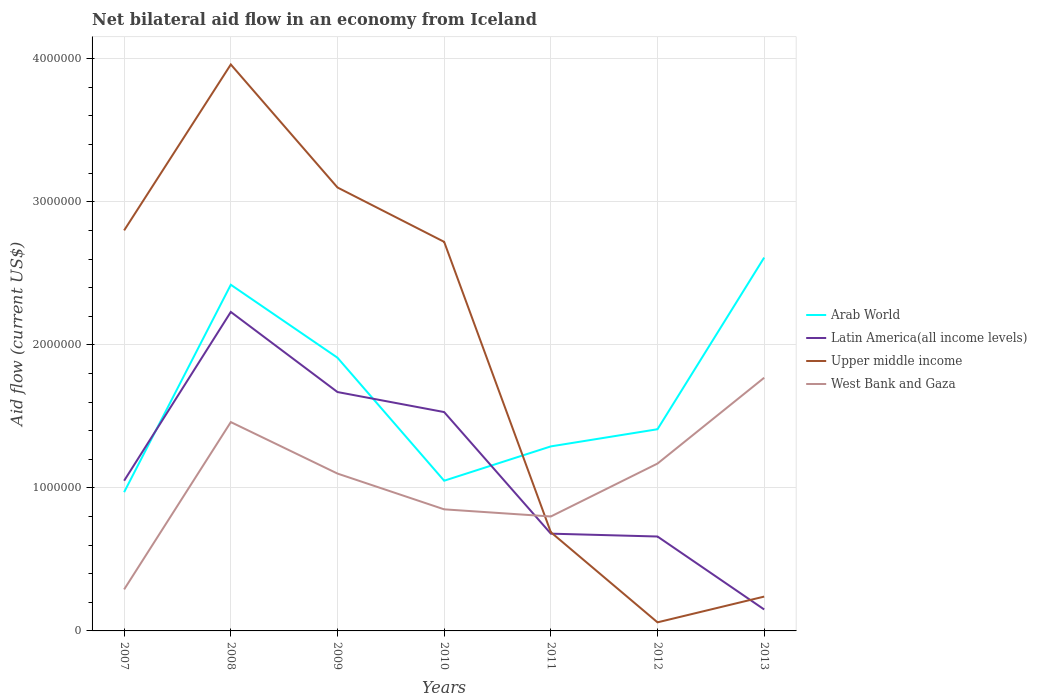Does the line corresponding to Upper middle income intersect with the line corresponding to Latin America(all income levels)?
Give a very brief answer. Yes. Is the number of lines equal to the number of legend labels?
Offer a terse response. Yes. What is the total net bilateral aid flow in West Bank and Gaza in the graph?
Your answer should be compact. -7.00e+04. What is the difference between the highest and the second highest net bilateral aid flow in Upper middle income?
Provide a short and direct response. 3.90e+06. How many lines are there?
Offer a terse response. 4. How many years are there in the graph?
Keep it short and to the point. 7. What is the difference between two consecutive major ticks on the Y-axis?
Ensure brevity in your answer.  1.00e+06. Does the graph contain any zero values?
Offer a very short reply. No. Does the graph contain grids?
Provide a short and direct response. Yes. Where does the legend appear in the graph?
Your answer should be compact. Center right. What is the title of the graph?
Provide a succinct answer. Net bilateral aid flow in an economy from Iceland. Does "South Sudan" appear as one of the legend labels in the graph?
Offer a terse response. No. What is the label or title of the Y-axis?
Your answer should be very brief. Aid flow (current US$). What is the Aid flow (current US$) of Arab World in 2007?
Your answer should be very brief. 9.70e+05. What is the Aid flow (current US$) of Latin America(all income levels) in 2007?
Your answer should be very brief. 1.05e+06. What is the Aid flow (current US$) of Upper middle income in 2007?
Keep it short and to the point. 2.80e+06. What is the Aid flow (current US$) in West Bank and Gaza in 2007?
Your answer should be compact. 2.90e+05. What is the Aid flow (current US$) of Arab World in 2008?
Offer a very short reply. 2.42e+06. What is the Aid flow (current US$) of Latin America(all income levels) in 2008?
Your response must be concise. 2.23e+06. What is the Aid flow (current US$) of Upper middle income in 2008?
Provide a short and direct response. 3.96e+06. What is the Aid flow (current US$) in West Bank and Gaza in 2008?
Offer a terse response. 1.46e+06. What is the Aid flow (current US$) in Arab World in 2009?
Ensure brevity in your answer.  1.91e+06. What is the Aid flow (current US$) in Latin America(all income levels) in 2009?
Provide a short and direct response. 1.67e+06. What is the Aid flow (current US$) in Upper middle income in 2009?
Make the answer very short. 3.10e+06. What is the Aid flow (current US$) of West Bank and Gaza in 2009?
Provide a short and direct response. 1.10e+06. What is the Aid flow (current US$) of Arab World in 2010?
Keep it short and to the point. 1.05e+06. What is the Aid flow (current US$) in Latin America(all income levels) in 2010?
Provide a short and direct response. 1.53e+06. What is the Aid flow (current US$) of Upper middle income in 2010?
Make the answer very short. 2.72e+06. What is the Aid flow (current US$) of West Bank and Gaza in 2010?
Your answer should be compact. 8.50e+05. What is the Aid flow (current US$) of Arab World in 2011?
Your response must be concise. 1.29e+06. What is the Aid flow (current US$) of Latin America(all income levels) in 2011?
Your answer should be compact. 6.80e+05. What is the Aid flow (current US$) in Upper middle income in 2011?
Keep it short and to the point. 6.90e+05. What is the Aid flow (current US$) of Arab World in 2012?
Provide a succinct answer. 1.41e+06. What is the Aid flow (current US$) of Upper middle income in 2012?
Provide a short and direct response. 6.00e+04. What is the Aid flow (current US$) in West Bank and Gaza in 2012?
Keep it short and to the point. 1.17e+06. What is the Aid flow (current US$) in Arab World in 2013?
Provide a short and direct response. 2.61e+06. What is the Aid flow (current US$) in West Bank and Gaza in 2013?
Your answer should be compact. 1.77e+06. Across all years, what is the maximum Aid flow (current US$) in Arab World?
Your answer should be very brief. 2.61e+06. Across all years, what is the maximum Aid flow (current US$) in Latin America(all income levels)?
Offer a very short reply. 2.23e+06. Across all years, what is the maximum Aid flow (current US$) in Upper middle income?
Keep it short and to the point. 3.96e+06. Across all years, what is the maximum Aid flow (current US$) of West Bank and Gaza?
Offer a very short reply. 1.77e+06. Across all years, what is the minimum Aid flow (current US$) in Arab World?
Your answer should be very brief. 9.70e+05. Across all years, what is the minimum Aid flow (current US$) in West Bank and Gaza?
Your answer should be compact. 2.90e+05. What is the total Aid flow (current US$) in Arab World in the graph?
Your response must be concise. 1.17e+07. What is the total Aid flow (current US$) of Latin America(all income levels) in the graph?
Your response must be concise. 7.97e+06. What is the total Aid flow (current US$) of Upper middle income in the graph?
Make the answer very short. 1.36e+07. What is the total Aid flow (current US$) of West Bank and Gaza in the graph?
Offer a very short reply. 7.44e+06. What is the difference between the Aid flow (current US$) of Arab World in 2007 and that in 2008?
Make the answer very short. -1.45e+06. What is the difference between the Aid flow (current US$) of Latin America(all income levels) in 2007 and that in 2008?
Offer a terse response. -1.18e+06. What is the difference between the Aid flow (current US$) in Upper middle income in 2007 and that in 2008?
Offer a terse response. -1.16e+06. What is the difference between the Aid flow (current US$) in West Bank and Gaza in 2007 and that in 2008?
Give a very brief answer. -1.17e+06. What is the difference between the Aid flow (current US$) in Arab World in 2007 and that in 2009?
Ensure brevity in your answer.  -9.40e+05. What is the difference between the Aid flow (current US$) in Latin America(all income levels) in 2007 and that in 2009?
Provide a succinct answer. -6.20e+05. What is the difference between the Aid flow (current US$) in West Bank and Gaza in 2007 and that in 2009?
Ensure brevity in your answer.  -8.10e+05. What is the difference between the Aid flow (current US$) in Arab World in 2007 and that in 2010?
Keep it short and to the point. -8.00e+04. What is the difference between the Aid flow (current US$) of Latin America(all income levels) in 2007 and that in 2010?
Provide a short and direct response. -4.80e+05. What is the difference between the Aid flow (current US$) in West Bank and Gaza in 2007 and that in 2010?
Make the answer very short. -5.60e+05. What is the difference between the Aid flow (current US$) of Arab World in 2007 and that in 2011?
Keep it short and to the point. -3.20e+05. What is the difference between the Aid flow (current US$) of Latin America(all income levels) in 2007 and that in 2011?
Provide a succinct answer. 3.70e+05. What is the difference between the Aid flow (current US$) in Upper middle income in 2007 and that in 2011?
Give a very brief answer. 2.11e+06. What is the difference between the Aid flow (current US$) of West Bank and Gaza in 2007 and that in 2011?
Give a very brief answer. -5.10e+05. What is the difference between the Aid flow (current US$) of Arab World in 2007 and that in 2012?
Provide a succinct answer. -4.40e+05. What is the difference between the Aid flow (current US$) in Upper middle income in 2007 and that in 2012?
Ensure brevity in your answer.  2.74e+06. What is the difference between the Aid flow (current US$) of West Bank and Gaza in 2007 and that in 2012?
Offer a very short reply. -8.80e+05. What is the difference between the Aid flow (current US$) of Arab World in 2007 and that in 2013?
Your answer should be compact. -1.64e+06. What is the difference between the Aid flow (current US$) in Latin America(all income levels) in 2007 and that in 2013?
Your answer should be compact. 9.00e+05. What is the difference between the Aid flow (current US$) in Upper middle income in 2007 and that in 2013?
Offer a very short reply. 2.56e+06. What is the difference between the Aid flow (current US$) in West Bank and Gaza in 2007 and that in 2013?
Offer a terse response. -1.48e+06. What is the difference between the Aid flow (current US$) in Arab World in 2008 and that in 2009?
Give a very brief answer. 5.10e+05. What is the difference between the Aid flow (current US$) of Latin America(all income levels) in 2008 and that in 2009?
Provide a short and direct response. 5.60e+05. What is the difference between the Aid flow (current US$) of Upper middle income in 2008 and that in 2009?
Keep it short and to the point. 8.60e+05. What is the difference between the Aid flow (current US$) in West Bank and Gaza in 2008 and that in 2009?
Give a very brief answer. 3.60e+05. What is the difference between the Aid flow (current US$) of Arab World in 2008 and that in 2010?
Offer a terse response. 1.37e+06. What is the difference between the Aid flow (current US$) of Upper middle income in 2008 and that in 2010?
Offer a terse response. 1.24e+06. What is the difference between the Aid flow (current US$) of West Bank and Gaza in 2008 and that in 2010?
Provide a short and direct response. 6.10e+05. What is the difference between the Aid flow (current US$) in Arab World in 2008 and that in 2011?
Ensure brevity in your answer.  1.13e+06. What is the difference between the Aid flow (current US$) in Latin America(all income levels) in 2008 and that in 2011?
Offer a terse response. 1.55e+06. What is the difference between the Aid flow (current US$) of Upper middle income in 2008 and that in 2011?
Your answer should be compact. 3.27e+06. What is the difference between the Aid flow (current US$) in West Bank and Gaza in 2008 and that in 2011?
Your answer should be very brief. 6.60e+05. What is the difference between the Aid flow (current US$) in Arab World in 2008 and that in 2012?
Your answer should be very brief. 1.01e+06. What is the difference between the Aid flow (current US$) of Latin America(all income levels) in 2008 and that in 2012?
Your answer should be very brief. 1.57e+06. What is the difference between the Aid flow (current US$) in Upper middle income in 2008 and that in 2012?
Give a very brief answer. 3.90e+06. What is the difference between the Aid flow (current US$) in Arab World in 2008 and that in 2013?
Make the answer very short. -1.90e+05. What is the difference between the Aid flow (current US$) in Latin America(all income levels) in 2008 and that in 2013?
Your answer should be compact. 2.08e+06. What is the difference between the Aid flow (current US$) of Upper middle income in 2008 and that in 2013?
Offer a very short reply. 3.72e+06. What is the difference between the Aid flow (current US$) of West Bank and Gaza in 2008 and that in 2013?
Your answer should be compact. -3.10e+05. What is the difference between the Aid flow (current US$) of Arab World in 2009 and that in 2010?
Your answer should be very brief. 8.60e+05. What is the difference between the Aid flow (current US$) in Latin America(all income levels) in 2009 and that in 2010?
Provide a succinct answer. 1.40e+05. What is the difference between the Aid flow (current US$) in West Bank and Gaza in 2009 and that in 2010?
Offer a very short reply. 2.50e+05. What is the difference between the Aid flow (current US$) of Arab World in 2009 and that in 2011?
Provide a succinct answer. 6.20e+05. What is the difference between the Aid flow (current US$) in Latin America(all income levels) in 2009 and that in 2011?
Ensure brevity in your answer.  9.90e+05. What is the difference between the Aid flow (current US$) in Upper middle income in 2009 and that in 2011?
Offer a terse response. 2.41e+06. What is the difference between the Aid flow (current US$) in Latin America(all income levels) in 2009 and that in 2012?
Keep it short and to the point. 1.01e+06. What is the difference between the Aid flow (current US$) in Upper middle income in 2009 and that in 2012?
Provide a succinct answer. 3.04e+06. What is the difference between the Aid flow (current US$) of Arab World in 2009 and that in 2013?
Ensure brevity in your answer.  -7.00e+05. What is the difference between the Aid flow (current US$) of Latin America(all income levels) in 2009 and that in 2013?
Your answer should be very brief. 1.52e+06. What is the difference between the Aid flow (current US$) of Upper middle income in 2009 and that in 2013?
Make the answer very short. 2.86e+06. What is the difference between the Aid flow (current US$) in West Bank and Gaza in 2009 and that in 2013?
Your answer should be compact. -6.70e+05. What is the difference between the Aid flow (current US$) of Latin America(all income levels) in 2010 and that in 2011?
Keep it short and to the point. 8.50e+05. What is the difference between the Aid flow (current US$) in Upper middle income in 2010 and that in 2011?
Give a very brief answer. 2.03e+06. What is the difference between the Aid flow (current US$) of Arab World in 2010 and that in 2012?
Ensure brevity in your answer.  -3.60e+05. What is the difference between the Aid flow (current US$) in Latin America(all income levels) in 2010 and that in 2012?
Provide a succinct answer. 8.70e+05. What is the difference between the Aid flow (current US$) of Upper middle income in 2010 and that in 2012?
Keep it short and to the point. 2.66e+06. What is the difference between the Aid flow (current US$) in West Bank and Gaza in 2010 and that in 2012?
Keep it short and to the point. -3.20e+05. What is the difference between the Aid flow (current US$) in Arab World in 2010 and that in 2013?
Your answer should be compact. -1.56e+06. What is the difference between the Aid flow (current US$) in Latin America(all income levels) in 2010 and that in 2013?
Offer a terse response. 1.38e+06. What is the difference between the Aid flow (current US$) of Upper middle income in 2010 and that in 2013?
Ensure brevity in your answer.  2.48e+06. What is the difference between the Aid flow (current US$) of West Bank and Gaza in 2010 and that in 2013?
Your answer should be very brief. -9.20e+05. What is the difference between the Aid flow (current US$) of Arab World in 2011 and that in 2012?
Your response must be concise. -1.20e+05. What is the difference between the Aid flow (current US$) of Upper middle income in 2011 and that in 2012?
Offer a terse response. 6.30e+05. What is the difference between the Aid flow (current US$) in West Bank and Gaza in 2011 and that in 2012?
Keep it short and to the point. -3.70e+05. What is the difference between the Aid flow (current US$) in Arab World in 2011 and that in 2013?
Your response must be concise. -1.32e+06. What is the difference between the Aid flow (current US$) in Latin America(all income levels) in 2011 and that in 2013?
Make the answer very short. 5.30e+05. What is the difference between the Aid flow (current US$) of West Bank and Gaza in 2011 and that in 2013?
Offer a very short reply. -9.70e+05. What is the difference between the Aid flow (current US$) of Arab World in 2012 and that in 2013?
Your answer should be very brief. -1.20e+06. What is the difference between the Aid flow (current US$) in Latin America(all income levels) in 2012 and that in 2013?
Make the answer very short. 5.10e+05. What is the difference between the Aid flow (current US$) in West Bank and Gaza in 2012 and that in 2013?
Give a very brief answer. -6.00e+05. What is the difference between the Aid flow (current US$) of Arab World in 2007 and the Aid flow (current US$) of Latin America(all income levels) in 2008?
Make the answer very short. -1.26e+06. What is the difference between the Aid flow (current US$) of Arab World in 2007 and the Aid flow (current US$) of Upper middle income in 2008?
Your response must be concise. -2.99e+06. What is the difference between the Aid flow (current US$) in Arab World in 2007 and the Aid flow (current US$) in West Bank and Gaza in 2008?
Your answer should be very brief. -4.90e+05. What is the difference between the Aid flow (current US$) of Latin America(all income levels) in 2007 and the Aid flow (current US$) of Upper middle income in 2008?
Your answer should be compact. -2.91e+06. What is the difference between the Aid flow (current US$) of Latin America(all income levels) in 2007 and the Aid flow (current US$) of West Bank and Gaza in 2008?
Your answer should be compact. -4.10e+05. What is the difference between the Aid flow (current US$) in Upper middle income in 2007 and the Aid flow (current US$) in West Bank and Gaza in 2008?
Provide a short and direct response. 1.34e+06. What is the difference between the Aid flow (current US$) in Arab World in 2007 and the Aid flow (current US$) in Latin America(all income levels) in 2009?
Give a very brief answer. -7.00e+05. What is the difference between the Aid flow (current US$) of Arab World in 2007 and the Aid flow (current US$) of Upper middle income in 2009?
Your answer should be very brief. -2.13e+06. What is the difference between the Aid flow (current US$) in Arab World in 2007 and the Aid flow (current US$) in West Bank and Gaza in 2009?
Offer a very short reply. -1.30e+05. What is the difference between the Aid flow (current US$) of Latin America(all income levels) in 2007 and the Aid flow (current US$) of Upper middle income in 2009?
Offer a terse response. -2.05e+06. What is the difference between the Aid flow (current US$) of Latin America(all income levels) in 2007 and the Aid flow (current US$) of West Bank and Gaza in 2009?
Your answer should be compact. -5.00e+04. What is the difference between the Aid flow (current US$) of Upper middle income in 2007 and the Aid flow (current US$) of West Bank and Gaza in 2009?
Give a very brief answer. 1.70e+06. What is the difference between the Aid flow (current US$) in Arab World in 2007 and the Aid flow (current US$) in Latin America(all income levels) in 2010?
Ensure brevity in your answer.  -5.60e+05. What is the difference between the Aid flow (current US$) in Arab World in 2007 and the Aid flow (current US$) in Upper middle income in 2010?
Your answer should be very brief. -1.75e+06. What is the difference between the Aid flow (current US$) of Latin America(all income levels) in 2007 and the Aid flow (current US$) of Upper middle income in 2010?
Make the answer very short. -1.67e+06. What is the difference between the Aid flow (current US$) in Upper middle income in 2007 and the Aid flow (current US$) in West Bank and Gaza in 2010?
Make the answer very short. 1.95e+06. What is the difference between the Aid flow (current US$) of Arab World in 2007 and the Aid flow (current US$) of Latin America(all income levels) in 2011?
Offer a terse response. 2.90e+05. What is the difference between the Aid flow (current US$) in Arab World in 2007 and the Aid flow (current US$) in Upper middle income in 2011?
Offer a terse response. 2.80e+05. What is the difference between the Aid flow (current US$) of Arab World in 2007 and the Aid flow (current US$) of West Bank and Gaza in 2011?
Your answer should be compact. 1.70e+05. What is the difference between the Aid flow (current US$) of Latin America(all income levels) in 2007 and the Aid flow (current US$) of West Bank and Gaza in 2011?
Your response must be concise. 2.50e+05. What is the difference between the Aid flow (current US$) of Upper middle income in 2007 and the Aid flow (current US$) of West Bank and Gaza in 2011?
Ensure brevity in your answer.  2.00e+06. What is the difference between the Aid flow (current US$) of Arab World in 2007 and the Aid flow (current US$) of Upper middle income in 2012?
Provide a short and direct response. 9.10e+05. What is the difference between the Aid flow (current US$) in Arab World in 2007 and the Aid flow (current US$) in West Bank and Gaza in 2012?
Your answer should be very brief. -2.00e+05. What is the difference between the Aid flow (current US$) of Latin America(all income levels) in 2007 and the Aid flow (current US$) of Upper middle income in 2012?
Ensure brevity in your answer.  9.90e+05. What is the difference between the Aid flow (current US$) of Upper middle income in 2007 and the Aid flow (current US$) of West Bank and Gaza in 2012?
Offer a terse response. 1.63e+06. What is the difference between the Aid flow (current US$) in Arab World in 2007 and the Aid flow (current US$) in Latin America(all income levels) in 2013?
Offer a terse response. 8.20e+05. What is the difference between the Aid flow (current US$) of Arab World in 2007 and the Aid flow (current US$) of Upper middle income in 2013?
Provide a short and direct response. 7.30e+05. What is the difference between the Aid flow (current US$) of Arab World in 2007 and the Aid flow (current US$) of West Bank and Gaza in 2013?
Offer a terse response. -8.00e+05. What is the difference between the Aid flow (current US$) of Latin America(all income levels) in 2007 and the Aid flow (current US$) of Upper middle income in 2013?
Give a very brief answer. 8.10e+05. What is the difference between the Aid flow (current US$) of Latin America(all income levels) in 2007 and the Aid flow (current US$) of West Bank and Gaza in 2013?
Offer a terse response. -7.20e+05. What is the difference between the Aid flow (current US$) in Upper middle income in 2007 and the Aid flow (current US$) in West Bank and Gaza in 2013?
Ensure brevity in your answer.  1.03e+06. What is the difference between the Aid flow (current US$) of Arab World in 2008 and the Aid flow (current US$) of Latin America(all income levels) in 2009?
Give a very brief answer. 7.50e+05. What is the difference between the Aid flow (current US$) in Arab World in 2008 and the Aid flow (current US$) in Upper middle income in 2009?
Make the answer very short. -6.80e+05. What is the difference between the Aid flow (current US$) of Arab World in 2008 and the Aid flow (current US$) of West Bank and Gaza in 2009?
Offer a terse response. 1.32e+06. What is the difference between the Aid flow (current US$) in Latin America(all income levels) in 2008 and the Aid flow (current US$) in Upper middle income in 2009?
Ensure brevity in your answer.  -8.70e+05. What is the difference between the Aid flow (current US$) in Latin America(all income levels) in 2008 and the Aid flow (current US$) in West Bank and Gaza in 2009?
Offer a very short reply. 1.13e+06. What is the difference between the Aid flow (current US$) in Upper middle income in 2008 and the Aid flow (current US$) in West Bank and Gaza in 2009?
Provide a succinct answer. 2.86e+06. What is the difference between the Aid flow (current US$) in Arab World in 2008 and the Aid flow (current US$) in Latin America(all income levels) in 2010?
Keep it short and to the point. 8.90e+05. What is the difference between the Aid flow (current US$) in Arab World in 2008 and the Aid flow (current US$) in Upper middle income in 2010?
Your answer should be compact. -3.00e+05. What is the difference between the Aid flow (current US$) in Arab World in 2008 and the Aid flow (current US$) in West Bank and Gaza in 2010?
Provide a short and direct response. 1.57e+06. What is the difference between the Aid flow (current US$) of Latin America(all income levels) in 2008 and the Aid flow (current US$) of Upper middle income in 2010?
Offer a terse response. -4.90e+05. What is the difference between the Aid flow (current US$) in Latin America(all income levels) in 2008 and the Aid flow (current US$) in West Bank and Gaza in 2010?
Make the answer very short. 1.38e+06. What is the difference between the Aid flow (current US$) of Upper middle income in 2008 and the Aid flow (current US$) of West Bank and Gaza in 2010?
Your answer should be compact. 3.11e+06. What is the difference between the Aid flow (current US$) of Arab World in 2008 and the Aid flow (current US$) of Latin America(all income levels) in 2011?
Provide a succinct answer. 1.74e+06. What is the difference between the Aid flow (current US$) in Arab World in 2008 and the Aid flow (current US$) in Upper middle income in 2011?
Make the answer very short. 1.73e+06. What is the difference between the Aid flow (current US$) of Arab World in 2008 and the Aid flow (current US$) of West Bank and Gaza in 2011?
Your answer should be compact. 1.62e+06. What is the difference between the Aid flow (current US$) in Latin America(all income levels) in 2008 and the Aid flow (current US$) in Upper middle income in 2011?
Your answer should be compact. 1.54e+06. What is the difference between the Aid flow (current US$) in Latin America(all income levels) in 2008 and the Aid flow (current US$) in West Bank and Gaza in 2011?
Keep it short and to the point. 1.43e+06. What is the difference between the Aid flow (current US$) of Upper middle income in 2008 and the Aid flow (current US$) of West Bank and Gaza in 2011?
Provide a short and direct response. 3.16e+06. What is the difference between the Aid flow (current US$) in Arab World in 2008 and the Aid flow (current US$) in Latin America(all income levels) in 2012?
Your response must be concise. 1.76e+06. What is the difference between the Aid flow (current US$) in Arab World in 2008 and the Aid flow (current US$) in Upper middle income in 2012?
Offer a very short reply. 2.36e+06. What is the difference between the Aid flow (current US$) of Arab World in 2008 and the Aid flow (current US$) of West Bank and Gaza in 2012?
Offer a terse response. 1.25e+06. What is the difference between the Aid flow (current US$) in Latin America(all income levels) in 2008 and the Aid flow (current US$) in Upper middle income in 2012?
Provide a succinct answer. 2.17e+06. What is the difference between the Aid flow (current US$) in Latin America(all income levels) in 2008 and the Aid flow (current US$) in West Bank and Gaza in 2012?
Your response must be concise. 1.06e+06. What is the difference between the Aid flow (current US$) of Upper middle income in 2008 and the Aid flow (current US$) of West Bank and Gaza in 2012?
Give a very brief answer. 2.79e+06. What is the difference between the Aid flow (current US$) of Arab World in 2008 and the Aid flow (current US$) of Latin America(all income levels) in 2013?
Provide a succinct answer. 2.27e+06. What is the difference between the Aid flow (current US$) in Arab World in 2008 and the Aid flow (current US$) in Upper middle income in 2013?
Give a very brief answer. 2.18e+06. What is the difference between the Aid flow (current US$) of Arab World in 2008 and the Aid flow (current US$) of West Bank and Gaza in 2013?
Give a very brief answer. 6.50e+05. What is the difference between the Aid flow (current US$) in Latin America(all income levels) in 2008 and the Aid flow (current US$) in Upper middle income in 2013?
Your answer should be compact. 1.99e+06. What is the difference between the Aid flow (current US$) in Latin America(all income levels) in 2008 and the Aid flow (current US$) in West Bank and Gaza in 2013?
Your response must be concise. 4.60e+05. What is the difference between the Aid flow (current US$) in Upper middle income in 2008 and the Aid flow (current US$) in West Bank and Gaza in 2013?
Offer a terse response. 2.19e+06. What is the difference between the Aid flow (current US$) in Arab World in 2009 and the Aid flow (current US$) in Upper middle income in 2010?
Make the answer very short. -8.10e+05. What is the difference between the Aid flow (current US$) of Arab World in 2009 and the Aid flow (current US$) of West Bank and Gaza in 2010?
Ensure brevity in your answer.  1.06e+06. What is the difference between the Aid flow (current US$) of Latin America(all income levels) in 2009 and the Aid flow (current US$) of Upper middle income in 2010?
Your response must be concise. -1.05e+06. What is the difference between the Aid flow (current US$) in Latin America(all income levels) in 2009 and the Aid flow (current US$) in West Bank and Gaza in 2010?
Your response must be concise. 8.20e+05. What is the difference between the Aid flow (current US$) of Upper middle income in 2009 and the Aid flow (current US$) of West Bank and Gaza in 2010?
Offer a terse response. 2.25e+06. What is the difference between the Aid flow (current US$) in Arab World in 2009 and the Aid flow (current US$) in Latin America(all income levels) in 2011?
Make the answer very short. 1.23e+06. What is the difference between the Aid flow (current US$) of Arab World in 2009 and the Aid flow (current US$) of Upper middle income in 2011?
Ensure brevity in your answer.  1.22e+06. What is the difference between the Aid flow (current US$) of Arab World in 2009 and the Aid flow (current US$) of West Bank and Gaza in 2011?
Make the answer very short. 1.11e+06. What is the difference between the Aid flow (current US$) of Latin America(all income levels) in 2009 and the Aid flow (current US$) of Upper middle income in 2011?
Keep it short and to the point. 9.80e+05. What is the difference between the Aid flow (current US$) of Latin America(all income levels) in 2009 and the Aid flow (current US$) of West Bank and Gaza in 2011?
Ensure brevity in your answer.  8.70e+05. What is the difference between the Aid flow (current US$) of Upper middle income in 2009 and the Aid flow (current US$) of West Bank and Gaza in 2011?
Ensure brevity in your answer.  2.30e+06. What is the difference between the Aid flow (current US$) of Arab World in 2009 and the Aid flow (current US$) of Latin America(all income levels) in 2012?
Give a very brief answer. 1.25e+06. What is the difference between the Aid flow (current US$) in Arab World in 2009 and the Aid flow (current US$) in Upper middle income in 2012?
Your answer should be compact. 1.85e+06. What is the difference between the Aid flow (current US$) of Arab World in 2009 and the Aid flow (current US$) of West Bank and Gaza in 2012?
Your response must be concise. 7.40e+05. What is the difference between the Aid flow (current US$) of Latin America(all income levels) in 2009 and the Aid flow (current US$) of Upper middle income in 2012?
Your answer should be compact. 1.61e+06. What is the difference between the Aid flow (current US$) in Latin America(all income levels) in 2009 and the Aid flow (current US$) in West Bank and Gaza in 2012?
Provide a succinct answer. 5.00e+05. What is the difference between the Aid flow (current US$) in Upper middle income in 2009 and the Aid flow (current US$) in West Bank and Gaza in 2012?
Your answer should be compact. 1.93e+06. What is the difference between the Aid flow (current US$) in Arab World in 2009 and the Aid flow (current US$) in Latin America(all income levels) in 2013?
Provide a short and direct response. 1.76e+06. What is the difference between the Aid flow (current US$) in Arab World in 2009 and the Aid flow (current US$) in Upper middle income in 2013?
Make the answer very short. 1.67e+06. What is the difference between the Aid flow (current US$) in Latin America(all income levels) in 2009 and the Aid flow (current US$) in Upper middle income in 2013?
Your response must be concise. 1.43e+06. What is the difference between the Aid flow (current US$) of Upper middle income in 2009 and the Aid flow (current US$) of West Bank and Gaza in 2013?
Offer a terse response. 1.33e+06. What is the difference between the Aid flow (current US$) in Arab World in 2010 and the Aid flow (current US$) in West Bank and Gaza in 2011?
Your response must be concise. 2.50e+05. What is the difference between the Aid flow (current US$) of Latin America(all income levels) in 2010 and the Aid flow (current US$) of Upper middle income in 2011?
Make the answer very short. 8.40e+05. What is the difference between the Aid flow (current US$) in Latin America(all income levels) in 2010 and the Aid flow (current US$) in West Bank and Gaza in 2011?
Ensure brevity in your answer.  7.30e+05. What is the difference between the Aid flow (current US$) of Upper middle income in 2010 and the Aid flow (current US$) of West Bank and Gaza in 2011?
Ensure brevity in your answer.  1.92e+06. What is the difference between the Aid flow (current US$) in Arab World in 2010 and the Aid flow (current US$) in Upper middle income in 2012?
Make the answer very short. 9.90e+05. What is the difference between the Aid flow (current US$) in Arab World in 2010 and the Aid flow (current US$) in West Bank and Gaza in 2012?
Give a very brief answer. -1.20e+05. What is the difference between the Aid flow (current US$) in Latin America(all income levels) in 2010 and the Aid flow (current US$) in Upper middle income in 2012?
Keep it short and to the point. 1.47e+06. What is the difference between the Aid flow (current US$) in Upper middle income in 2010 and the Aid flow (current US$) in West Bank and Gaza in 2012?
Offer a terse response. 1.55e+06. What is the difference between the Aid flow (current US$) of Arab World in 2010 and the Aid flow (current US$) of Latin America(all income levels) in 2013?
Your answer should be very brief. 9.00e+05. What is the difference between the Aid flow (current US$) in Arab World in 2010 and the Aid flow (current US$) in Upper middle income in 2013?
Offer a very short reply. 8.10e+05. What is the difference between the Aid flow (current US$) of Arab World in 2010 and the Aid flow (current US$) of West Bank and Gaza in 2013?
Provide a succinct answer. -7.20e+05. What is the difference between the Aid flow (current US$) of Latin America(all income levels) in 2010 and the Aid flow (current US$) of Upper middle income in 2013?
Provide a succinct answer. 1.29e+06. What is the difference between the Aid flow (current US$) of Upper middle income in 2010 and the Aid flow (current US$) of West Bank and Gaza in 2013?
Your answer should be compact. 9.50e+05. What is the difference between the Aid flow (current US$) in Arab World in 2011 and the Aid flow (current US$) in Latin America(all income levels) in 2012?
Give a very brief answer. 6.30e+05. What is the difference between the Aid flow (current US$) of Arab World in 2011 and the Aid flow (current US$) of Upper middle income in 2012?
Offer a terse response. 1.23e+06. What is the difference between the Aid flow (current US$) in Arab World in 2011 and the Aid flow (current US$) in West Bank and Gaza in 2012?
Provide a succinct answer. 1.20e+05. What is the difference between the Aid flow (current US$) of Latin America(all income levels) in 2011 and the Aid flow (current US$) of Upper middle income in 2012?
Your answer should be very brief. 6.20e+05. What is the difference between the Aid flow (current US$) in Latin America(all income levels) in 2011 and the Aid flow (current US$) in West Bank and Gaza in 2012?
Keep it short and to the point. -4.90e+05. What is the difference between the Aid flow (current US$) of Upper middle income in 2011 and the Aid flow (current US$) of West Bank and Gaza in 2012?
Give a very brief answer. -4.80e+05. What is the difference between the Aid flow (current US$) in Arab World in 2011 and the Aid flow (current US$) in Latin America(all income levels) in 2013?
Your response must be concise. 1.14e+06. What is the difference between the Aid flow (current US$) in Arab World in 2011 and the Aid flow (current US$) in Upper middle income in 2013?
Offer a terse response. 1.05e+06. What is the difference between the Aid flow (current US$) of Arab World in 2011 and the Aid flow (current US$) of West Bank and Gaza in 2013?
Provide a succinct answer. -4.80e+05. What is the difference between the Aid flow (current US$) of Latin America(all income levels) in 2011 and the Aid flow (current US$) of Upper middle income in 2013?
Your response must be concise. 4.40e+05. What is the difference between the Aid flow (current US$) of Latin America(all income levels) in 2011 and the Aid flow (current US$) of West Bank and Gaza in 2013?
Ensure brevity in your answer.  -1.09e+06. What is the difference between the Aid flow (current US$) in Upper middle income in 2011 and the Aid flow (current US$) in West Bank and Gaza in 2013?
Your response must be concise. -1.08e+06. What is the difference between the Aid flow (current US$) of Arab World in 2012 and the Aid flow (current US$) of Latin America(all income levels) in 2013?
Offer a terse response. 1.26e+06. What is the difference between the Aid flow (current US$) of Arab World in 2012 and the Aid flow (current US$) of Upper middle income in 2013?
Offer a very short reply. 1.17e+06. What is the difference between the Aid flow (current US$) in Arab World in 2012 and the Aid flow (current US$) in West Bank and Gaza in 2013?
Keep it short and to the point. -3.60e+05. What is the difference between the Aid flow (current US$) in Latin America(all income levels) in 2012 and the Aid flow (current US$) in West Bank and Gaza in 2013?
Provide a short and direct response. -1.11e+06. What is the difference between the Aid flow (current US$) of Upper middle income in 2012 and the Aid flow (current US$) of West Bank and Gaza in 2013?
Offer a very short reply. -1.71e+06. What is the average Aid flow (current US$) in Arab World per year?
Ensure brevity in your answer.  1.67e+06. What is the average Aid flow (current US$) of Latin America(all income levels) per year?
Offer a terse response. 1.14e+06. What is the average Aid flow (current US$) of Upper middle income per year?
Make the answer very short. 1.94e+06. What is the average Aid flow (current US$) of West Bank and Gaza per year?
Ensure brevity in your answer.  1.06e+06. In the year 2007, what is the difference between the Aid flow (current US$) of Arab World and Aid flow (current US$) of Upper middle income?
Offer a terse response. -1.83e+06. In the year 2007, what is the difference between the Aid flow (current US$) of Arab World and Aid flow (current US$) of West Bank and Gaza?
Your answer should be compact. 6.80e+05. In the year 2007, what is the difference between the Aid flow (current US$) of Latin America(all income levels) and Aid flow (current US$) of Upper middle income?
Give a very brief answer. -1.75e+06. In the year 2007, what is the difference between the Aid flow (current US$) in Latin America(all income levels) and Aid flow (current US$) in West Bank and Gaza?
Your response must be concise. 7.60e+05. In the year 2007, what is the difference between the Aid flow (current US$) in Upper middle income and Aid flow (current US$) in West Bank and Gaza?
Your response must be concise. 2.51e+06. In the year 2008, what is the difference between the Aid flow (current US$) in Arab World and Aid flow (current US$) in Latin America(all income levels)?
Ensure brevity in your answer.  1.90e+05. In the year 2008, what is the difference between the Aid flow (current US$) in Arab World and Aid flow (current US$) in Upper middle income?
Your answer should be compact. -1.54e+06. In the year 2008, what is the difference between the Aid flow (current US$) of Arab World and Aid flow (current US$) of West Bank and Gaza?
Your answer should be compact. 9.60e+05. In the year 2008, what is the difference between the Aid flow (current US$) in Latin America(all income levels) and Aid flow (current US$) in Upper middle income?
Your answer should be compact. -1.73e+06. In the year 2008, what is the difference between the Aid flow (current US$) of Latin America(all income levels) and Aid flow (current US$) of West Bank and Gaza?
Your answer should be compact. 7.70e+05. In the year 2008, what is the difference between the Aid flow (current US$) of Upper middle income and Aid flow (current US$) of West Bank and Gaza?
Your answer should be compact. 2.50e+06. In the year 2009, what is the difference between the Aid flow (current US$) of Arab World and Aid flow (current US$) of Latin America(all income levels)?
Provide a short and direct response. 2.40e+05. In the year 2009, what is the difference between the Aid flow (current US$) in Arab World and Aid flow (current US$) in Upper middle income?
Offer a terse response. -1.19e+06. In the year 2009, what is the difference between the Aid flow (current US$) in Arab World and Aid flow (current US$) in West Bank and Gaza?
Provide a succinct answer. 8.10e+05. In the year 2009, what is the difference between the Aid flow (current US$) in Latin America(all income levels) and Aid flow (current US$) in Upper middle income?
Your answer should be compact. -1.43e+06. In the year 2009, what is the difference between the Aid flow (current US$) in Latin America(all income levels) and Aid flow (current US$) in West Bank and Gaza?
Offer a terse response. 5.70e+05. In the year 2010, what is the difference between the Aid flow (current US$) of Arab World and Aid flow (current US$) of Latin America(all income levels)?
Offer a very short reply. -4.80e+05. In the year 2010, what is the difference between the Aid flow (current US$) of Arab World and Aid flow (current US$) of Upper middle income?
Provide a succinct answer. -1.67e+06. In the year 2010, what is the difference between the Aid flow (current US$) in Latin America(all income levels) and Aid flow (current US$) in Upper middle income?
Make the answer very short. -1.19e+06. In the year 2010, what is the difference between the Aid flow (current US$) of Latin America(all income levels) and Aid flow (current US$) of West Bank and Gaza?
Offer a terse response. 6.80e+05. In the year 2010, what is the difference between the Aid flow (current US$) in Upper middle income and Aid flow (current US$) in West Bank and Gaza?
Provide a short and direct response. 1.87e+06. In the year 2011, what is the difference between the Aid flow (current US$) of Arab World and Aid flow (current US$) of Latin America(all income levels)?
Your answer should be very brief. 6.10e+05. In the year 2011, what is the difference between the Aid flow (current US$) of Upper middle income and Aid flow (current US$) of West Bank and Gaza?
Make the answer very short. -1.10e+05. In the year 2012, what is the difference between the Aid flow (current US$) in Arab World and Aid flow (current US$) in Latin America(all income levels)?
Provide a succinct answer. 7.50e+05. In the year 2012, what is the difference between the Aid flow (current US$) of Arab World and Aid flow (current US$) of Upper middle income?
Your response must be concise. 1.35e+06. In the year 2012, what is the difference between the Aid flow (current US$) of Arab World and Aid flow (current US$) of West Bank and Gaza?
Provide a short and direct response. 2.40e+05. In the year 2012, what is the difference between the Aid flow (current US$) of Latin America(all income levels) and Aid flow (current US$) of West Bank and Gaza?
Give a very brief answer. -5.10e+05. In the year 2012, what is the difference between the Aid flow (current US$) of Upper middle income and Aid flow (current US$) of West Bank and Gaza?
Give a very brief answer. -1.11e+06. In the year 2013, what is the difference between the Aid flow (current US$) of Arab World and Aid flow (current US$) of Latin America(all income levels)?
Provide a short and direct response. 2.46e+06. In the year 2013, what is the difference between the Aid flow (current US$) of Arab World and Aid flow (current US$) of Upper middle income?
Offer a terse response. 2.37e+06. In the year 2013, what is the difference between the Aid flow (current US$) in Arab World and Aid flow (current US$) in West Bank and Gaza?
Keep it short and to the point. 8.40e+05. In the year 2013, what is the difference between the Aid flow (current US$) of Latin America(all income levels) and Aid flow (current US$) of West Bank and Gaza?
Keep it short and to the point. -1.62e+06. In the year 2013, what is the difference between the Aid flow (current US$) in Upper middle income and Aid flow (current US$) in West Bank and Gaza?
Provide a succinct answer. -1.53e+06. What is the ratio of the Aid flow (current US$) of Arab World in 2007 to that in 2008?
Make the answer very short. 0.4. What is the ratio of the Aid flow (current US$) in Latin America(all income levels) in 2007 to that in 2008?
Your answer should be very brief. 0.47. What is the ratio of the Aid flow (current US$) in Upper middle income in 2007 to that in 2008?
Offer a terse response. 0.71. What is the ratio of the Aid flow (current US$) of West Bank and Gaza in 2007 to that in 2008?
Make the answer very short. 0.2. What is the ratio of the Aid flow (current US$) in Arab World in 2007 to that in 2009?
Give a very brief answer. 0.51. What is the ratio of the Aid flow (current US$) of Latin America(all income levels) in 2007 to that in 2009?
Offer a very short reply. 0.63. What is the ratio of the Aid flow (current US$) of Upper middle income in 2007 to that in 2009?
Your response must be concise. 0.9. What is the ratio of the Aid flow (current US$) in West Bank and Gaza in 2007 to that in 2009?
Provide a succinct answer. 0.26. What is the ratio of the Aid flow (current US$) in Arab World in 2007 to that in 2010?
Give a very brief answer. 0.92. What is the ratio of the Aid flow (current US$) in Latin America(all income levels) in 2007 to that in 2010?
Provide a succinct answer. 0.69. What is the ratio of the Aid flow (current US$) in Upper middle income in 2007 to that in 2010?
Provide a succinct answer. 1.03. What is the ratio of the Aid flow (current US$) of West Bank and Gaza in 2007 to that in 2010?
Provide a short and direct response. 0.34. What is the ratio of the Aid flow (current US$) in Arab World in 2007 to that in 2011?
Offer a very short reply. 0.75. What is the ratio of the Aid flow (current US$) in Latin America(all income levels) in 2007 to that in 2011?
Keep it short and to the point. 1.54. What is the ratio of the Aid flow (current US$) in Upper middle income in 2007 to that in 2011?
Your answer should be compact. 4.06. What is the ratio of the Aid flow (current US$) in West Bank and Gaza in 2007 to that in 2011?
Your answer should be very brief. 0.36. What is the ratio of the Aid flow (current US$) of Arab World in 2007 to that in 2012?
Make the answer very short. 0.69. What is the ratio of the Aid flow (current US$) in Latin America(all income levels) in 2007 to that in 2012?
Provide a succinct answer. 1.59. What is the ratio of the Aid flow (current US$) in Upper middle income in 2007 to that in 2012?
Provide a short and direct response. 46.67. What is the ratio of the Aid flow (current US$) of West Bank and Gaza in 2007 to that in 2012?
Ensure brevity in your answer.  0.25. What is the ratio of the Aid flow (current US$) of Arab World in 2007 to that in 2013?
Make the answer very short. 0.37. What is the ratio of the Aid flow (current US$) in Latin America(all income levels) in 2007 to that in 2013?
Your answer should be very brief. 7. What is the ratio of the Aid flow (current US$) in Upper middle income in 2007 to that in 2013?
Provide a succinct answer. 11.67. What is the ratio of the Aid flow (current US$) in West Bank and Gaza in 2007 to that in 2013?
Offer a terse response. 0.16. What is the ratio of the Aid flow (current US$) in Arab World in 2008 to that in 2009?
Your response must be concise. 1.27. What is the ratio of the Aid flow (current US$) in Latin America(all income levels) in 2008 to that in 2009?
Ensure brevity in your answer.  1.34. What is the ratio of the Aid flow (current US$) of Upper middle income in 2008 to that in 2009?
Provide a short and direct response. 1.28. What is the ratio of the Aid flow (current US$) in West Bank and Gaza in 2008 to that in 2009?
Your answer should be very brief. 1.33. What is the ratio of the Aid flow (current US$) of Arab World in 2008 to that in 2010?
Your response must be concise. 2.3. What is the ratio of the Aid flow (current US$) of Latin America(all income levels) in 2008 to that in 2010?
Provide a short and direct response. 1.46. What is the ratio of the Aid flow (current US$) in Upper middle income in 2008 to that in 2010?
Provide a succinct answer. 1.46. What is the ratio of the Aid flow (current US$) of West Bank and Gaza in 2008 to that in 2010?
Your response must be concise. 1.72. What is the ratio of the Aid flow (current US$) in Arab World in 2008 to that in 2011?
Your response must be concise. 1.88. What is the ratio of the Aid flow (current US$) of Latin America(all income levels) in 2008 to that in 2011?
Ensure brevity in your answer.  3.28. What is the ratio of the Aid flow (current US$) in Upper middle income in 2008 to that in 2011?
Keep it short and to the point. 5.74. What is the ratio of the Aid flow (current US$) of West Bank and Gaza in 2008 to that in 2011?
Your answer should be very brief. 1.82. What is the ratio of the Aid flow (current US$) in Arab World in 2008 to that in 2012?
Make the answer very short. 1.72. What is the ratio of the Aid flow (current US$) in Latin America(all income levels) in 2008 to that in 2012?
Provide a short and direct response. 3.38. What is the ratio of the Aid flow (current US$) of Upper middle income in 2008 to that in 2012?
Your answer should be compact. 66. What is the ratio of the Aid flow (current US$) in West Bank and Gaza in 2008 to that in 2012?
Provide a succinct answer. 1.25. What is the ratio of the Aid flow (current US$) in Arab World in 2008 to that in 2013?
Your answer should be compact. 0.93. What is the ratio of the Aid flow (current US$) in Latin America(all income levels) in 2008 to that in 2013?
Offer a terse response. 14.87. What is the ratio of the Aid flow (current US$) in Upper middle income in 2008 to that in 2013?
Your response must be concise. 16.5. What is the ratio of the Aid flow (current US$) in West Bank and Gaza in 2008 to that in 2013?
Offer a terse response. 0.82. What is the ratio of the Aid flow (current US$) in Arab World in 2009 to that in 2010?
Your answer should be very brief. 1.82. What is the ratio of the Aid flow (current US$) of Latin America(all income levels) in 2009 to that in 2010?
Your answer should be very brief. 1.09. What is the ratio of the Aid flow (current US$) in Upper middle income in 2009 to that in 2010?
Make the answer very short. 1.14. What is the ratio of the Aid flow (current US$) in West Bank and Gaza in 2009 to that in 2010?
Offer a very short reply. 1.29. What is the ratio of the Aid flow (current US$) in Arab World in 2009 to that in 2011?
Offer a very short reply. 1.48. What is the ratio of the Aid flow (current US$) of Latin America(all income levels) in 2009 to that in 2011?
Keep it short and to the point. 2.46. What is the ratio of the Aid flow (current US$) in Upper middle income in 2009 to that in 2011?
Give a very brief answer. 4.49. What is the ratio of the Aid flow (current US$) of West Bank and Gaza in 2009 to that in 2011?
Your answer should be compact. 1.38. What is the ratio of the Aid flow (current US$) of Arab World in 2009 to that in 2012?
Provide a short and direct response. 1.35. What is the ratio of the Aid flow (current US$) in Latin America(all income levels) in 2009 to that in 2012?
Your answer should be compact. 2.53. What is the ratio of the Aid flow (current US$) of Upper middle income in 2009 to that in 2012?
Ensure brevity in your answer.  51.67. What is the ratio of the Aid flow (current US$) in West Bank and Gaza in 2009 to that in 2012?
Your answer should be very brief. 0.94. What is the ratio of the Aid flow (current US$) in Arab World in 2009 to that in 2013?
Give a very brief answer. 0.73. What is the ratio of the Aid flow (current US$) in Latin America(all income levels) in 2009 to that in 2013?
Ensure brevity in your answer.  11.13. What is the ratio of the Aid flow (current US$) in Upper middle income in 2009 to that in 2013?
Provide a succinct answer. 12.92. What is the ratio of the Aid flow (current US$) of West Bank and Gaza in 2009 to that in 2013?
Provide a short and direct response. 0.62. What is the ratio of the Aid flow (current US$) of Arab World in 2010 to that in 2011?
Keep it short and to the point. 0.81. What is the ratio of the Aid flow (current US$) of Latin America(all income levels) in 2010 to that in 2011?
Provide a succinct answer. 2.25. What is the ratio of the Aid flow (current US$) of Upper middle income in 2010 to that in 2011?
Provide a succinct answer. 3.94. What is the ratio of the Aid flow (current US$) of West Bank and Gaza in 2010 to that in 2011?
Your answer should be compact. 1.06. What is the ratio of the Aid flow (current US$) of Arab World in 2010 to that in 2012?
Ensure brevity in your answer.  0.74. What is the ratio of the Aid flow (current US$) in Latin America(all income levels) in 2010 to that in 2012?
Ensure brevity in your answer.  2.32. What is the ratio of the Aid flow (current US$) in Upper middle income in 2010 to that in 2012?
Your answer should be compact. 45.33. What is the ratio of the Aid flow (current US$) in West Bank and Gaza in 2010 to that in 2012?
Give a very brief answer. 0.73. What is the ratio of the Aid flow (current US$) in Arab World in 2010 to that in 2013?
Your response must be concise. 0.4. What is the ratio of the Aid flow (current US$) in Upper middle income in 2010 to that in 2013?
Offer a very short reply. 11.33. What is the ratio of the Aid flow (current US$) in West Bank and Gaza in 2010 to that in 2013?
Offer a terse response. 0.48. What is the ratio of the Aid flow (current US$) of Arab World in 2011 to that in 2012?
Provide a short and direct response. 0.91. What is the ratio of the Aid flow (current US$) of Latin America(all income levels) in 2011 to that in 2012?
Offer a terse response. 1.03. What is the ratio of the Aid flow (current US$) of Upper middle income in 2011 to that in 2012?
Ensure brevity in your answer.  11.5. What is the ratio of the Aid flow (current US$) in West Bank and Gaza in 2011 to that in 2012?
Offer a terse response. 0.68. What is the ratio of the Aid flow (current US$) in Arab World in 2011 to that in 2013?
Your answer should be very brief. 0.49. What is the ratio of the Aid flow (current US$) in Latin America(all income levels) in 2011 to that in 2013?
Your answer should be compact. 4.53. What is the ratio of the Aid flow (current US$) of Upper middle income in 2011 to that in 2013?
Provide a succinct answer. 2.88. What is the ratio of the Aid flow (current US$) of West Bank and Gaza in 2011 to that in 2013?
Your answer should be compact. 0.45. What is the ratio of the Aid flow (current US$) of Arab World in 2012 to that in 2013?
Your answer should be very brief. 0.54. What is the ratio of the Aid flow (current US$) in Upper middle income in 2012 to that in 2013?
Ensure brevity in your answer.  0.25. What is the ratio of the Aid flow (current US$) in West Bank and Gaza in 2012 to that in 2013?
Provide a short and direct response. 0.66. What is the difference between the highest and the second highest Aid flow (current US$) in Arab World?
Ensure brevity in your answer.  1.90e+05. What is the difference between the highest and the second highest Aid flow (current US$) of Latin America(all income levels)?
Offer a terse response. 5.60e+05. What is the difference between the highest and the second highest Aid flow (current US$) in Upper middle income?
Provide a succinct answer. 8.60e+05. What is the difference between the highest and the lowest Aid flow (current US$) of Arab World?
Your answer should be very brief. 1.64e+06. What is the difference between the highest and the lowest Aid flow (current US$) in Latin America(all income levels)?
Your response must be concise. 2.08e+06. What is the difference between the highest and the lowest Aid flow (current US$) in Upper middle income?
Ensure brevity in your answer.  3.90e+06. What is the difference between the highest and the lowest Aid flow (current US$) of West Bank and Gaza?
Make the answer very short. 1.48e+06. 